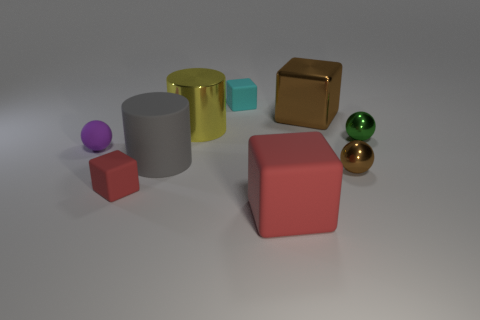Does the metal thing that is left of the large matte cube have the same color as the ball on the left side of the small brown shiny sphere?
Provide a short and direct response. No. Are there more tiny brown balls that are behind the large gray matte cylinder than large brown metal objects that are to the right of the tiny brown thing?
Provide a succinct answer. No. What is the tiny red object made of?
Your answer should be very brief. Rubber. What is the shape of the brown metal object that is left of the brown thing that is in front of the big brown shiny cube that is left of the brown metallic ball?
Make the answer very short. Cube. What number of other things are there of the same material as the brown sphere
Your answer should be compact. 3. Is the cyan object that is right of the yellow metal cylinder made of the same material as the small thing that is in front of the tiny brown thing?
Keep it short and to the point. Yes. How many things are both to the right of the cyan matte cube and in front of the matte sphere?
Your answer should be very brief. 2. Is there a large red metal object that has the same shape as the large gray object?
Provide a succinct answer. No. There is a brown shiny thing that is the same size as the gray matte cylinder; what shape is it?
Give a very brief answer. Cube. Are there the same number of large yellow cylinders that are to the left of the green object and yellow objects on the left side of the tiny red thing?
Provide a short and direct response. No. 